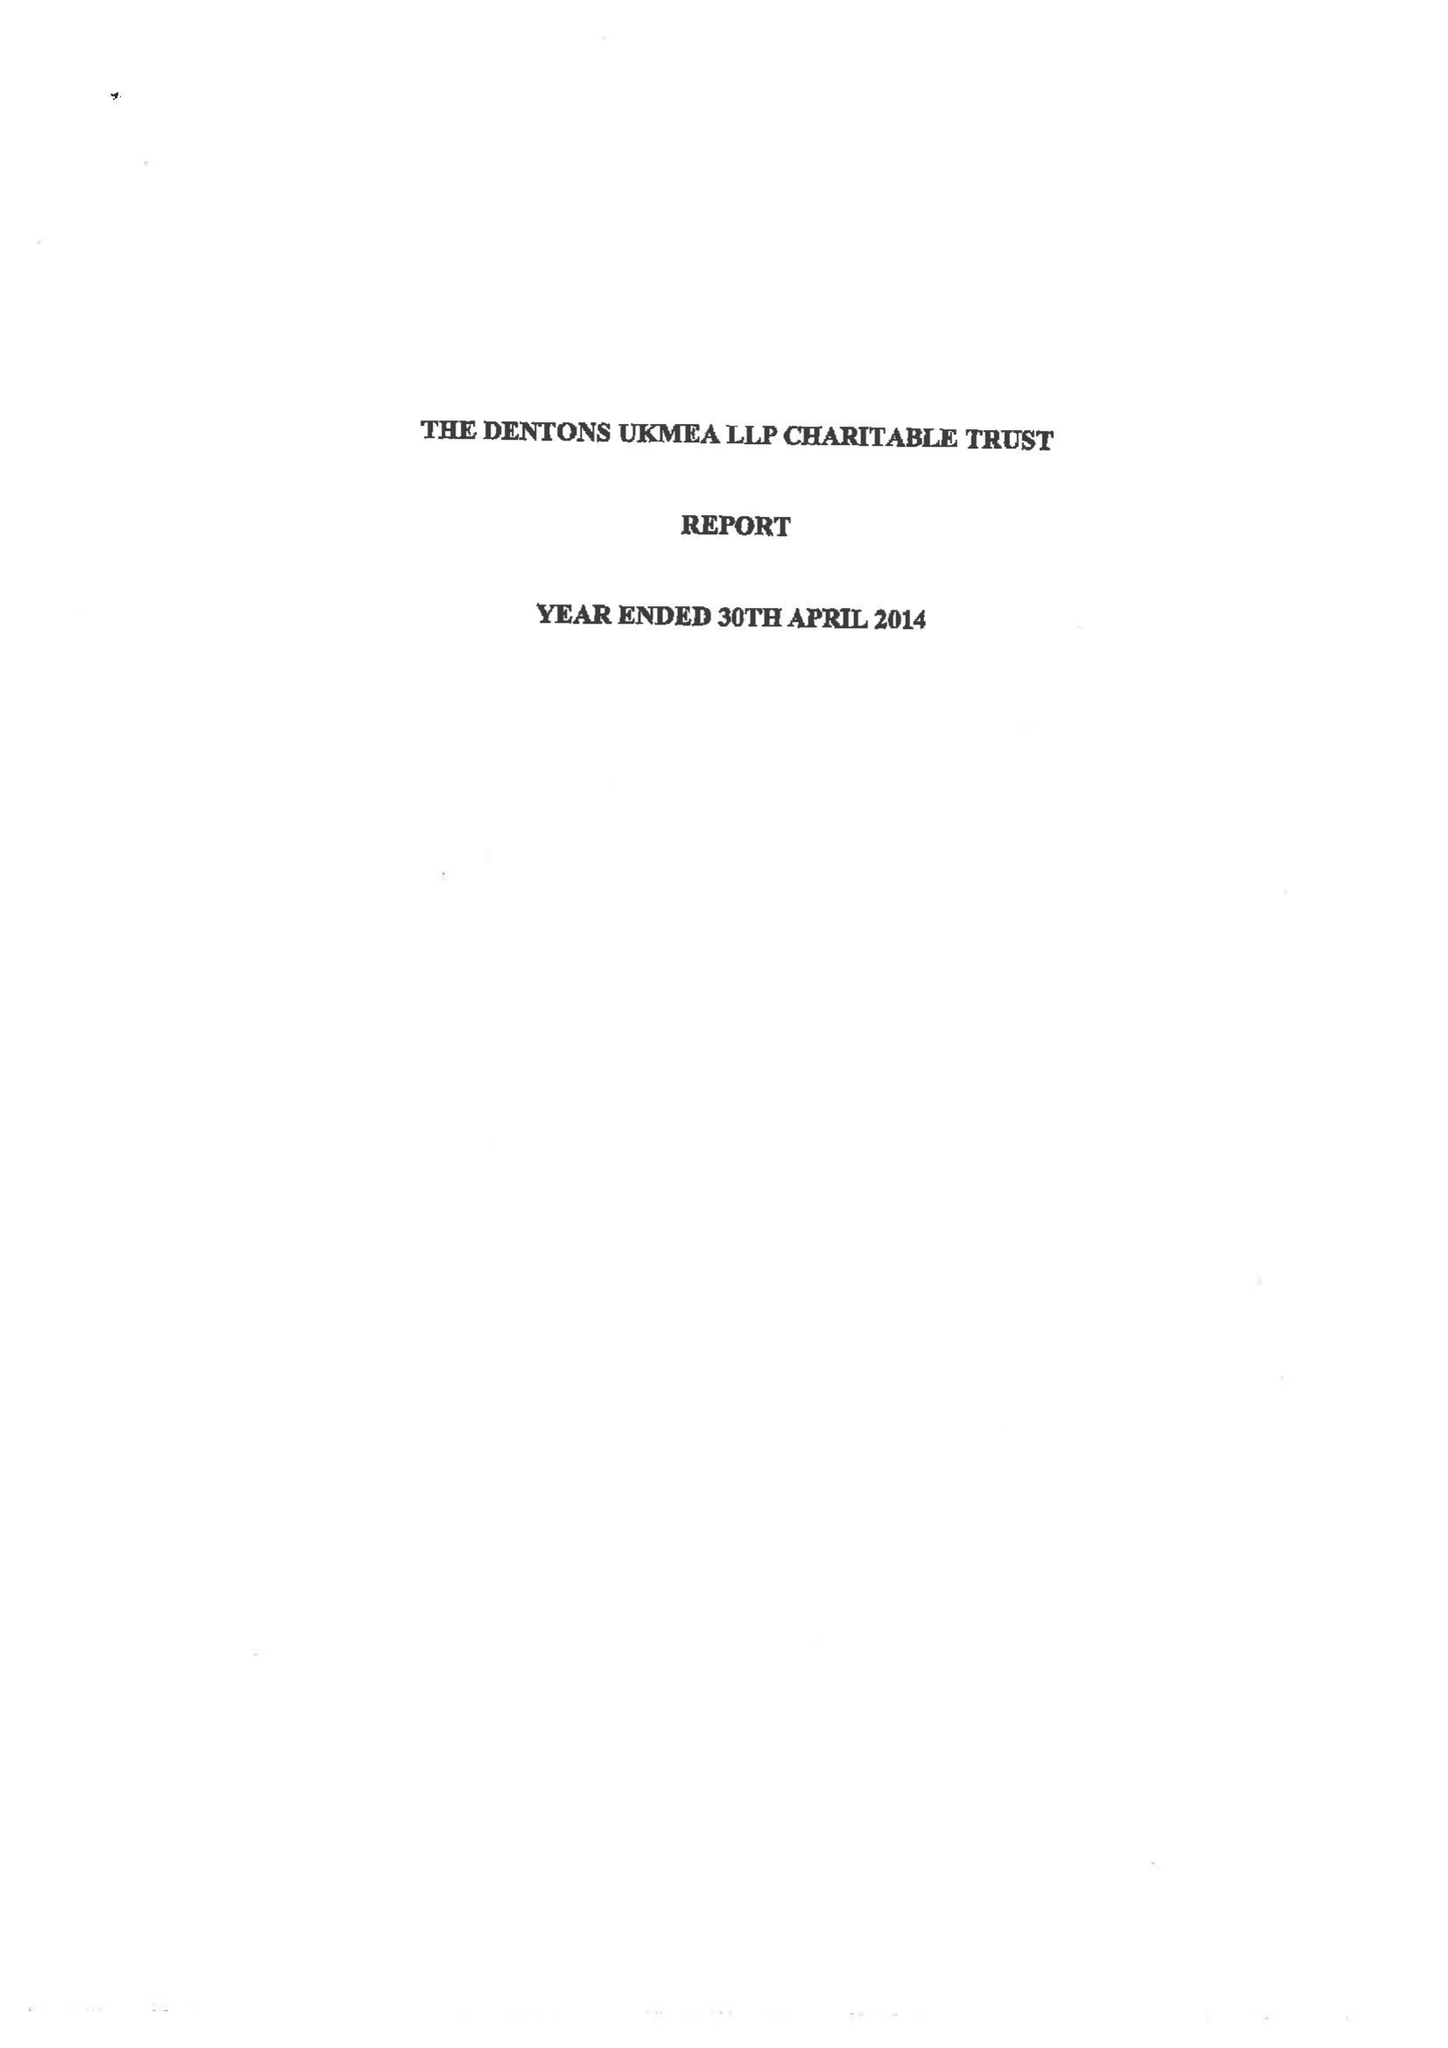What is the value for the charity_name?
Answer the question using a single word or phrase. Dentons Ukmea LLP 